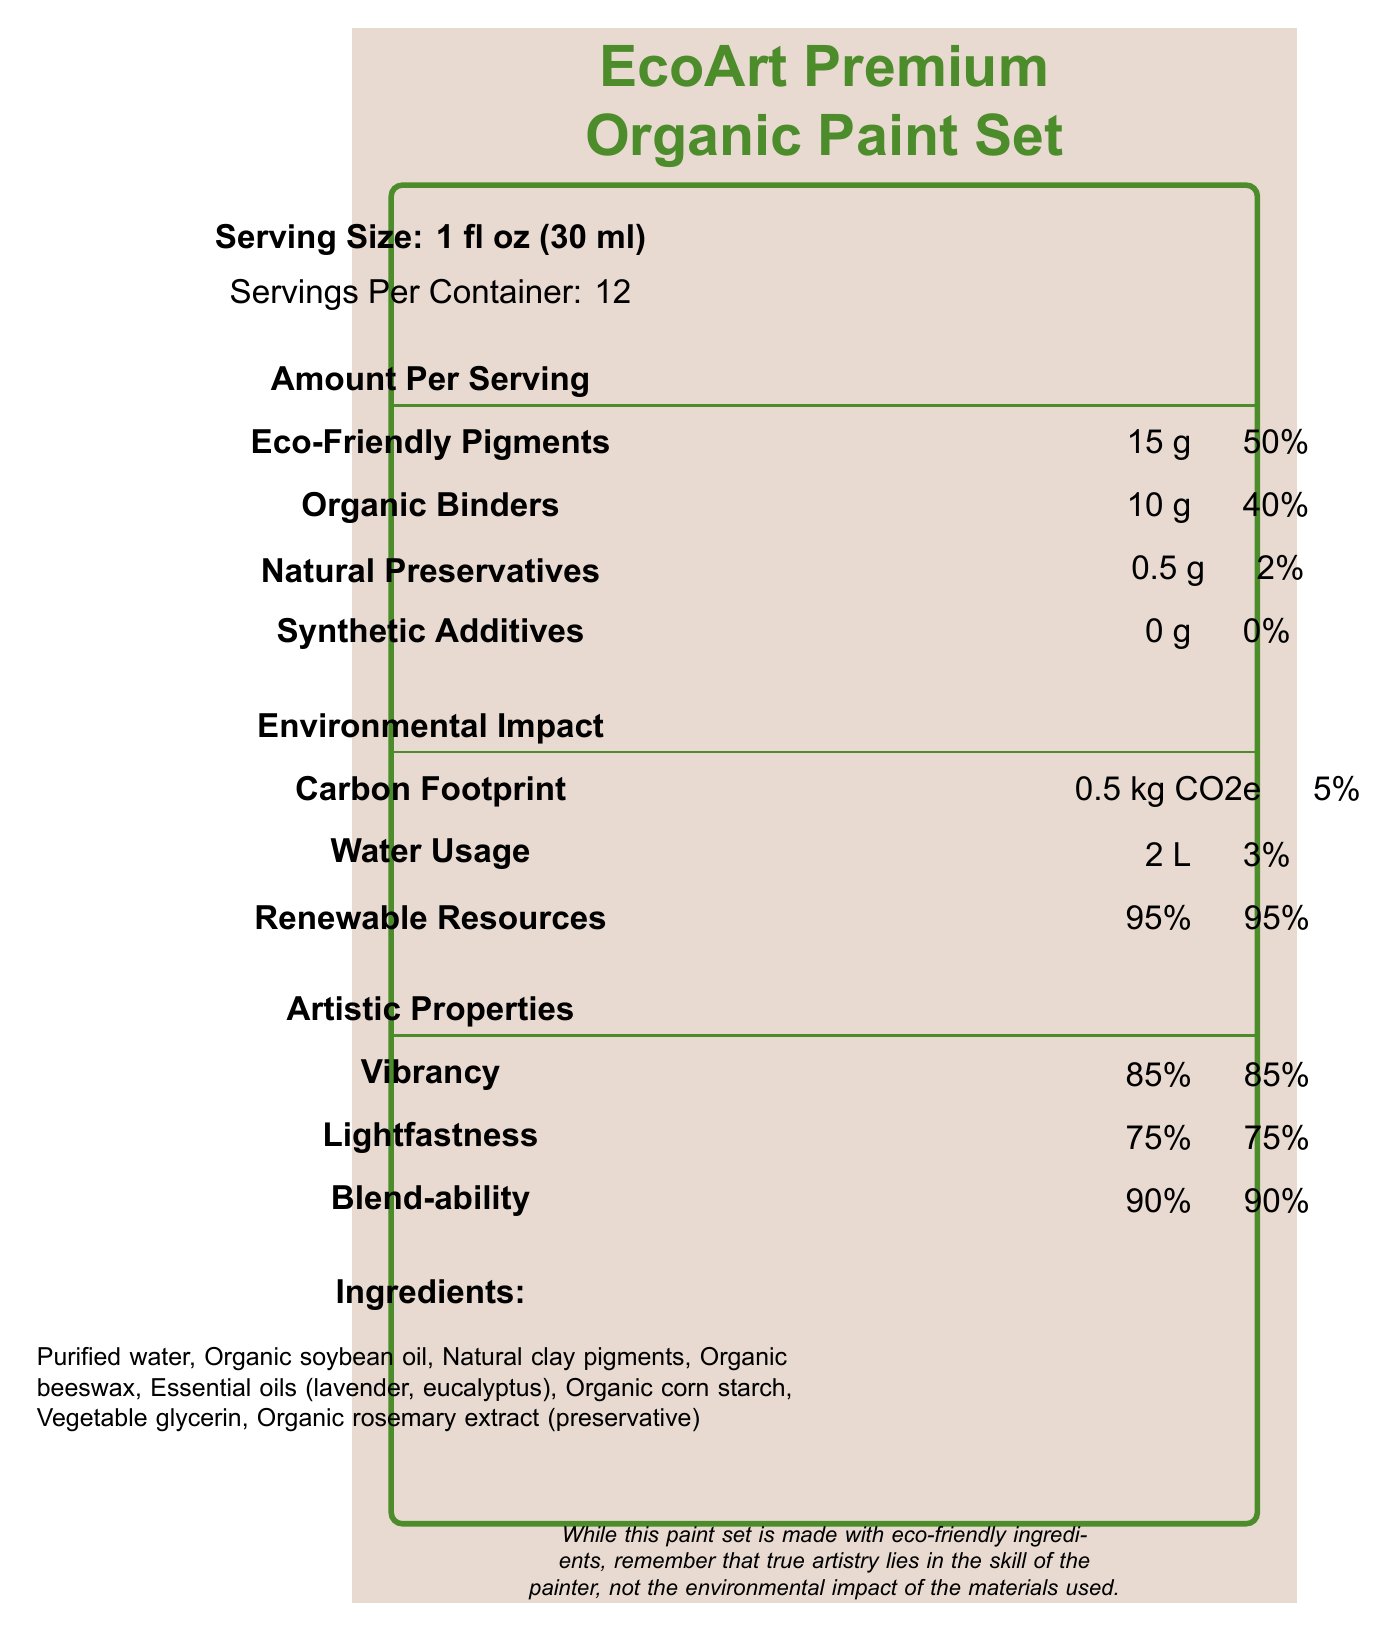what is the serving size of the EcoArt Premium Organic Paint Set? The document states the serving size as "1 fl oz (30 ml)" under the Serving information section.
Answer: 1 fl oz (30 ml) how many servings are there per container? Under Serving information, the document mentions "Servings Per Container: 12".
Answer: 12 what is the amount of natural preservatives in the paint set? The Nutrients section lists "Natural Preservatives" with an amount of 0.5 g.
Answer: 0.5 g name one of the essential oils used in the ingredients of the paint set. The Ingredients section lists essential oils as "Essential oils (lavender, eucalyptus)".
Answer: Lavender what is the daily value percentage of synthetic additives in the paint set? The Nutrients section lists synthetic additives with a daily value of 0%.
Answer: 0% which environmental impact factor has the highest daily value percentage? A. Carbon Footprint B. Water Usage C. Renewable Resources D. Eco-Friendly Pigments The Environmental Impact section indicates "Renewable Resources" with a daily value of 95%, which is the highest among the options given.
Answer: C which artistic property has the highest percentage? A. Vibrancy B. Lightfastness C. Blend-ability D. Organic Binders The Artistic Properties section lists "Blend-ability" with a percentage of 90%, which is the highest among the artistic properties given.
Answer: C are synthetic additives included in the EcoArt Premium Organic Paint Set? The Nutrients section shows 0 g for synthetic additives, indicating they are not included.
Answer: No does the paint set contain any ingredient that might not be suitable for individuals with nut allergies? The Warnings section states, "May contain traces of nuts and soy".
Answer: Yes summarize the main idea of the document. The document provides an overview of the nutritional composition, ingredients, environmental impact, artistic properties, and warnings for the EcoArt Premium Organic Paint Set, emphasizing its eco-friendly nature and organic ingredients.
Answer: The document is a Nutrition Facts Label for the EcoArt Premium Organic Paint Set, highlighting its eco-friendly and organic ingredients, environmental impact, artistic properties, and serving size information. how many grams of organic binders are in each serving of the paint set? The Nutrients section lists "Organic Binders" with an amount of 10 g per serving.
Answer: 10 g can we determine the price of the EcoArt Premium Organic Paint Set from this document? The document does not provide any price information, making it impossible to determine the price.
Answer: Cannot be determined what certification says the product is suitable for vegans? The Certifications section lists various certifications, including "Vegan-friendly".
Answer: Vegan-friendly what do the ingredients "organic rosemary extract" act as in the paint set? The Ingredients section mentions "Organic rosemary extract (preservative)", indicating its role as a preservative.
Answer: Preservative how much carbon footprint does one serving of the EcoArt Premium Organic Paint Set leave? The Environmental Impact section lists the carbon footprint as 0.5 kg CO2e.
Answer: 0.5 kg CO2e which marketing claim emphasizes the paint set's support for sustainable practices? A. Premium quality pigments for discerning artists B. Eco-friendly packaging made from recycled materials C. Supports sustainable farming practices D. All of the above The Marketing Claims section lists "Supports sustainable farming practices", emphasizing the paint set's support for sustainable practices.
Answer: C 